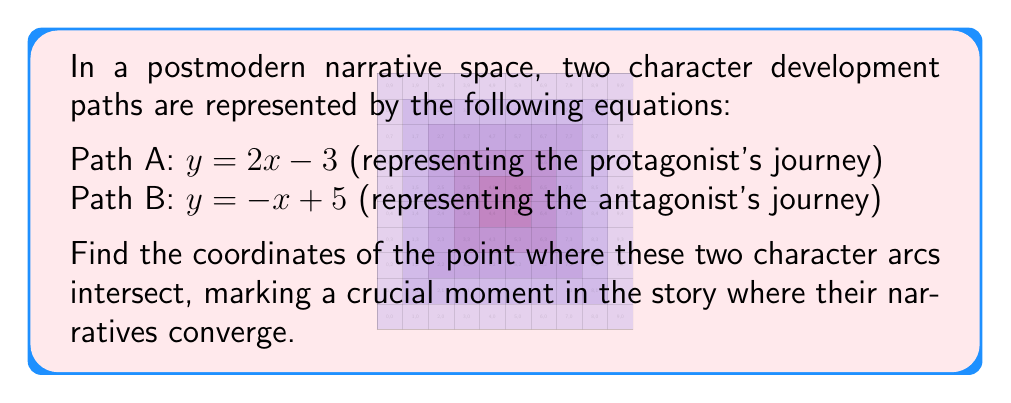Solve this math problem. To find the intersection point of these two character development paths, we need to solve the system of equations:

1) First, let's set the two equations equal to each other:
   $2x - 3 = -x + 5$

2) Now, we solve for x:
   $2x - 3 = -x + 5$
   $2x + x = 5 + 3$
   $3x = 8$
   $x = \frac{8}{3}$

3) To find y, we can substitute this x-value into either of the original equations. Let's use Path A:
   $y = 2x - 3$
   $y = 2(\frac{8}{3}) - 3$
   $y = \frac{16}{3} - 3$
   $y = \frac{16}{3} - \frac{9}{3}$
   $y = \frac{7}{3}$

4) Therefore, the point of intersection is $(\frac{8}{3}, \frac{7}{3})$

This point represents the moment in the narrative where the protagonist's and antagonist's paths intersect, creating a pivotal moment in the postmodern story structure.
Answer: $(\frac{8}{3}, \frac{7}{3})$ 